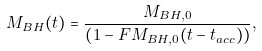<formula> <loc_0><loc_0><loc_500><loc_500>M _ { B H } ( t ) = \frac { M _ { B H , 0 } } { \left ( 1 - F M _ { B H , 0 } ( t - t _ { a c c } ) \right ) } ,</formula> 